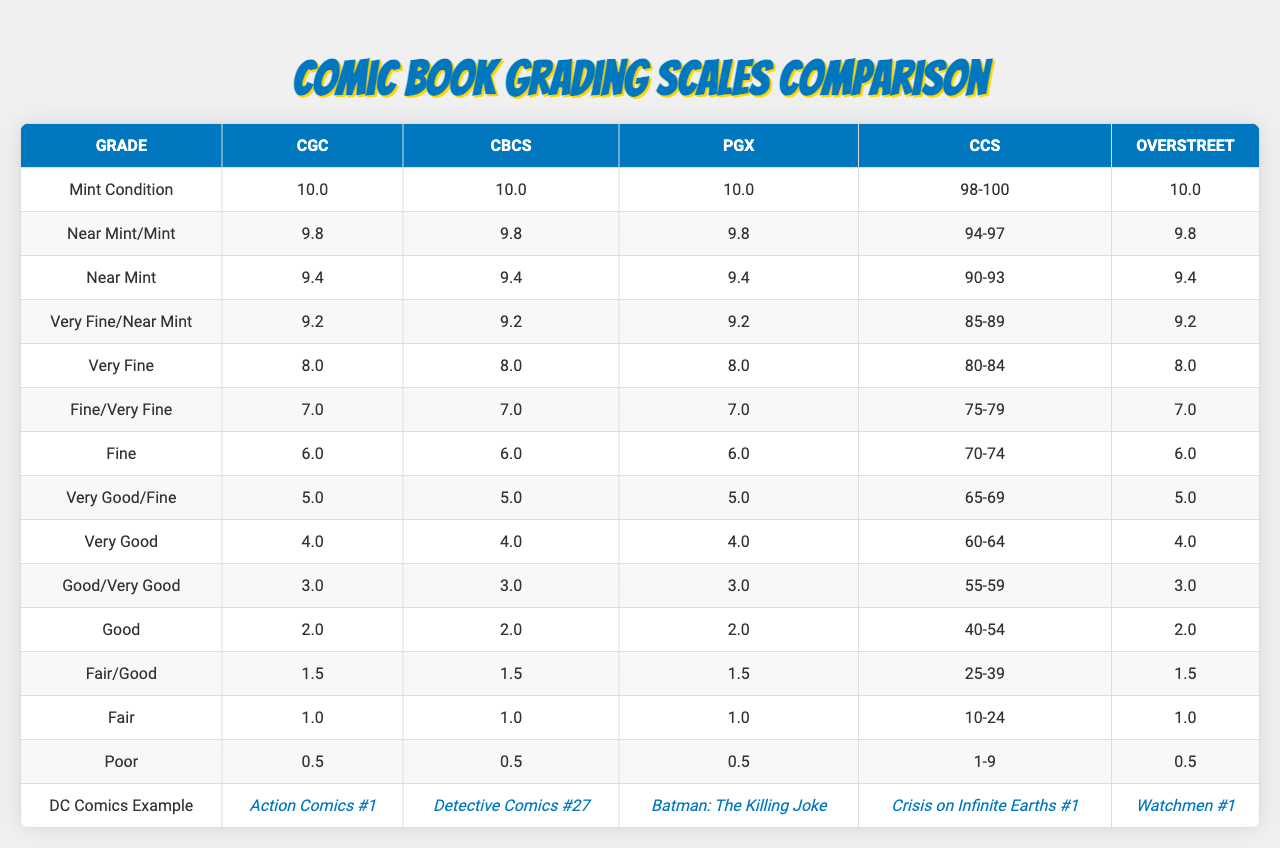What is the Mint Condition grade for CGC? In the table under "Mint Condition," the value for CGC is listed as "10.0"
Answer: 10.0 What is the equivalent grade for Very Fine from CBCS? The grade for Very Fine from CBCS is "8.0," as given in the corresponding row of the table
Answer: 8.0 Which grading company has the lowest grade listed, and what is that grade? The lowest grade listed in the table is "0.5," and it corresponds to all grading companies like CGC, CBCS, and PGX
Answer: 0.5 Is the Near Mint grade the same across all companies? Referencing the grades for Near Mint in the table, all companies show a grade of "9.4" for Near Mint
Answer: Yes What is the average Mint Condition grade across CGC, CBCS, and PGX? The Mint Condition grades for CGC, CBCS, and PGX are all 10.0. Therefore, the average of (10.0 + 10.0 + 10.0) / 3 = 10.0
Answer: 10.0 Which company has the highest grade for Fair, and what is that grade in comparison to others? From the table, the Fair grade is the same across all companies, at "1.0." This means no company has a higher Fair grade than the others
Answer: 1.0 What is the grade listed for Overstreet under the condition "Very Good"? Under the "Very Good" condition, Overstreet has a grade of "4.0" as seen in the corresponding row of the table
Answer: 4.0 How many grading companies have a Near Mint/Mint grade of 9.8? In the table, CGC, CBCS, and PGX all have a Near Mint/Mint grade of "9.8," totaling three grading companies
Answer: 3 Which comic book is used as an example for PGX's grading? According to the "DC Comics Example" list, "Batman: The Killing Joke" is highlighted as the example for PGX
Answer: Batman: The Killing Joke Is there a grading company that uses a range for any grade? Yes, CCS and Overstreet both provide ranges for certain grades; for CCS, "Very Fine" is "98-100," and for Overstreet, "Fine" is "70-74"
Answer: Yes 